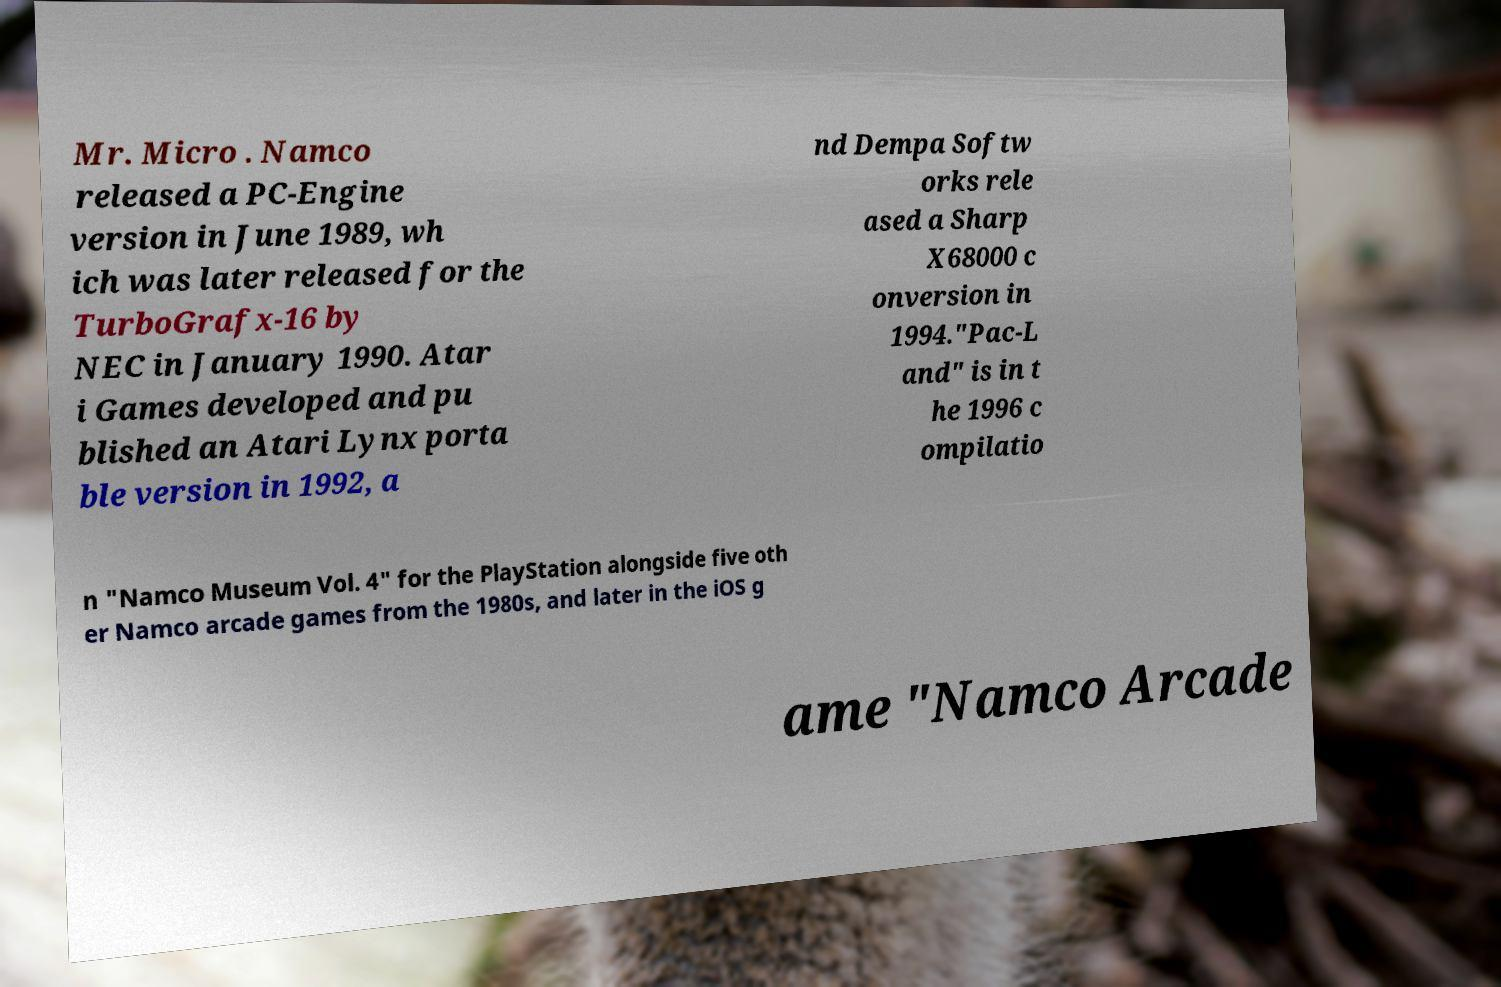Can you read and provide the text displayed in the image?This photo seems to have some interesting text. Can you extract and type it out for me? Mr. Micro . Namco released a PC-Engine version in June 1989, wh ich was later released for the TurboGrafx-16 by NEC in January 1990. Atar i Games developed and pu blished an Atari Lynx porta ble version in 1992, a nd Dempa Softw orks rele ased a Sharp X68000 c onversion in 1994."Pac-L and" is in t he 1996 c ompilatio n "Namco Museum Vol. 4" for the PlayStation alongside five oth er Namco arcade games from the 1980s, and later in the iOS g ame "Namco Arcade 